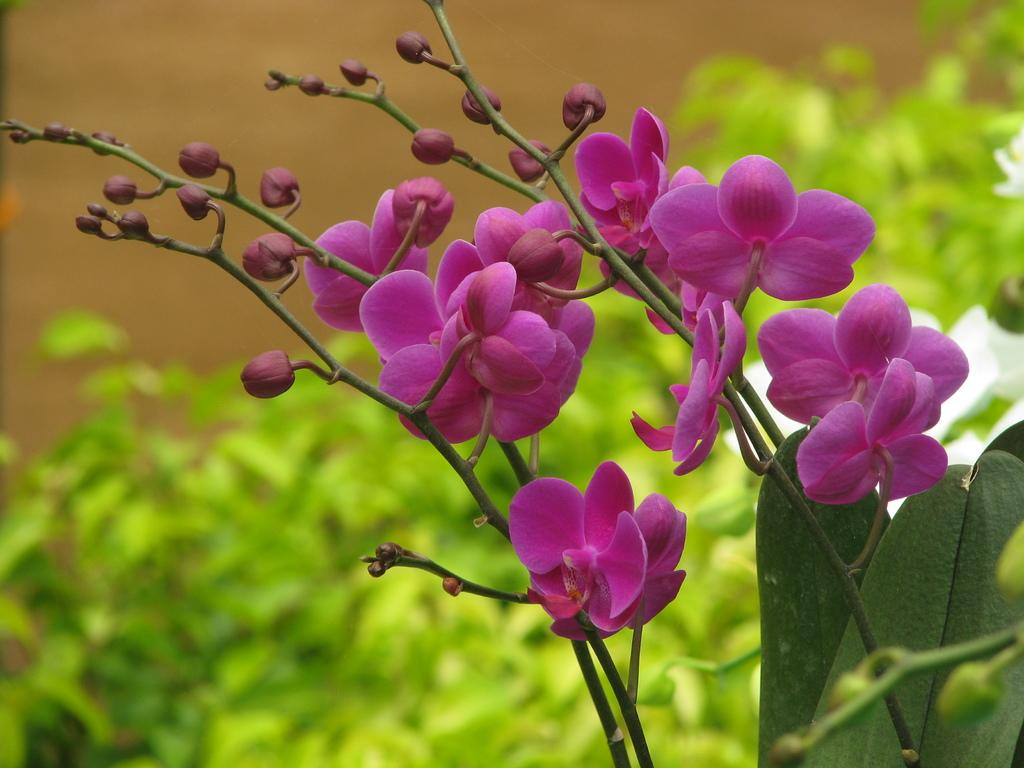What type of flowers can be seen in the image? There are beautiful flowers with pink color in the image. What is the color of the buds in the image? The buds in the image also have a pink color. What can be seen at the back side of the image? There are bushes at the back side of the image. How many children are playing with celery in the image? There are no children or celery present in the image; it features flowers and bushes. What type of machine can be seen operating in the background of the image? There is no machine present in the image; it is a nature scene with flowers and bushes. 